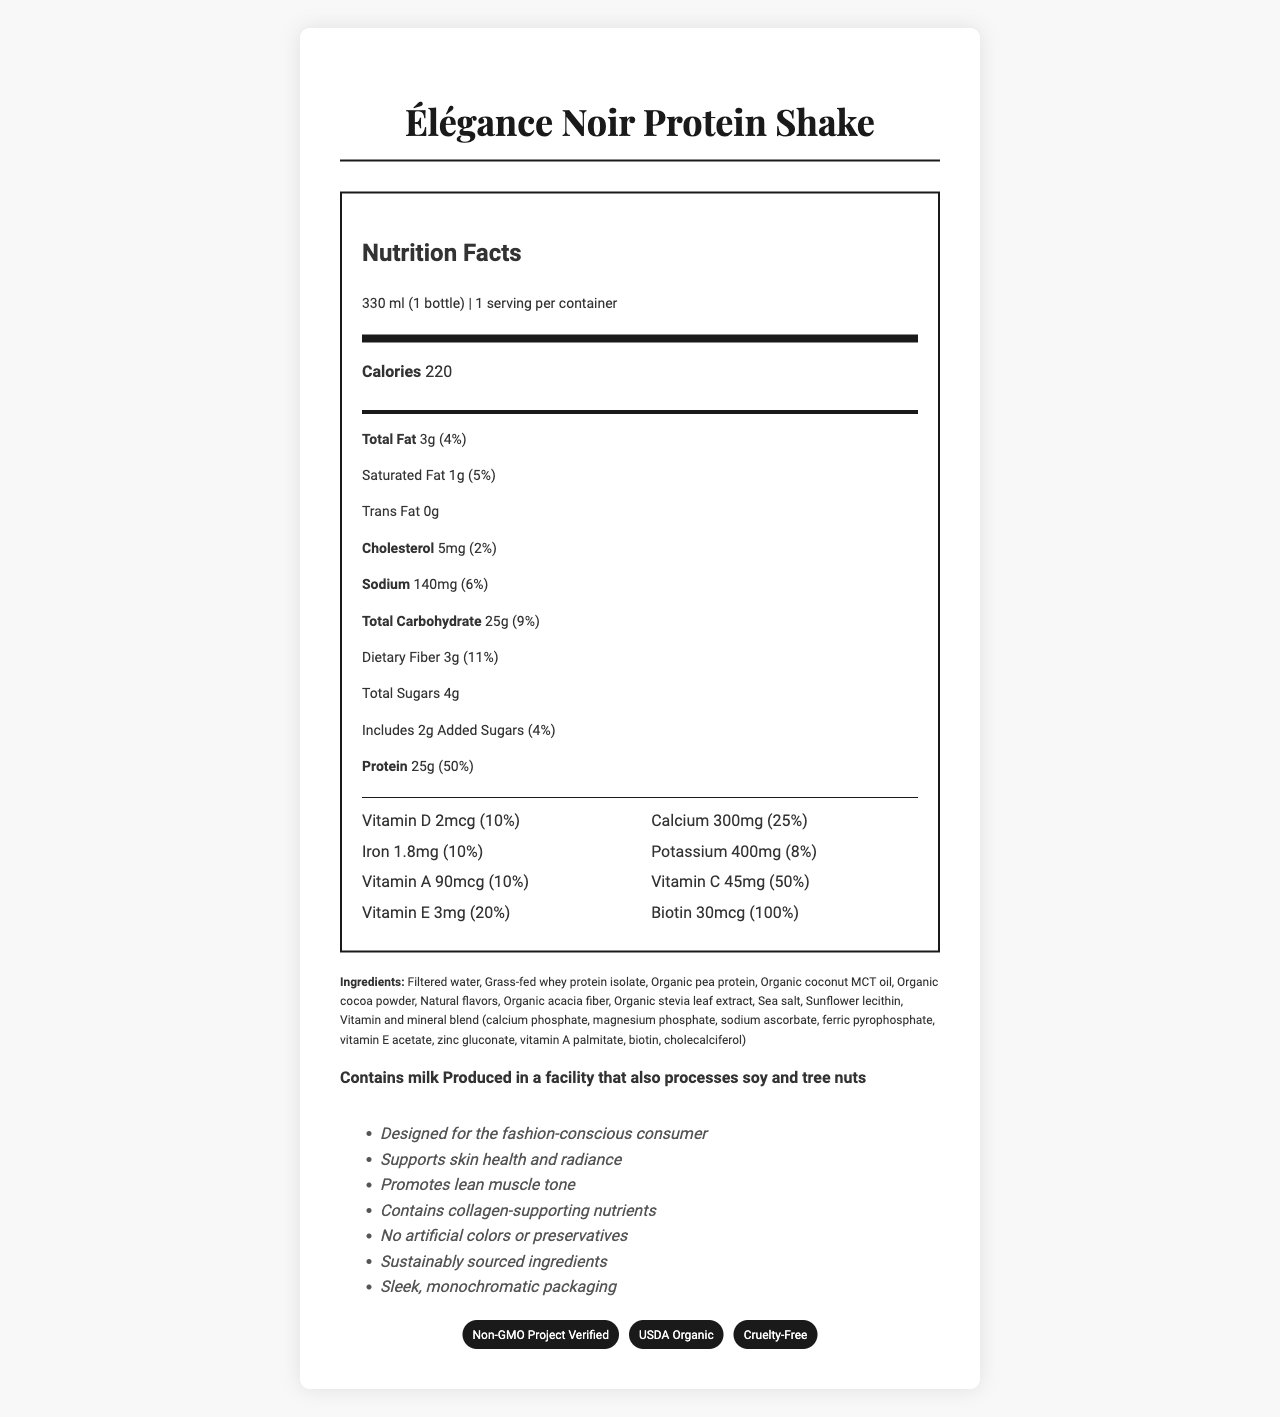what is the product name? The document clearly states the product name at the top, and in the title.
Answer: Élégance Noir Protein Shake what is the serving size for Élégance Noir Protein Shake? The serving size is mentioned in the "serving info" section just under the nutrition facts label header.
Answer: 330 ml (1 bottle) how many calories are in one serving of Élégance Noir Protein Shake? The calories count is prominently displayed in the main nutrients section.
Answer: 220 calories how much total fat does the product contain per serving? The amount of total fat is listed in the sub-nutrients section under the Total Fat label.
Answer: 3g how much protein does the shake provide per serving? The protein content is highlighted under the Protein label in the sub-nutrients section, with a Daily Value of 50%.
Answer: 25g how much added sugars are in this protein shake? The added sugars are documented in the sub-nutrients section, labeled as "Includes 2g Added Sugars (4%)".
Answer: 2g which vitamin has the highest daily value percentage? A. Vitamin D B. Vitamin E C. Vitamin C The Vitamin C amount is 45mg, which equals 50% of the daily value.
Answer: C. Vitamin C which claim is NOT made about the Élégance Noir Protein Shake? A. Contains collagen-supporting nutrients B. Promotes brain health C. No artificial colors or preservatives D. Supports skin health and radiance This claim is not listed in the marketing claims section.
Answer: B. Promotes brain health is it suitable for someone with a milk allergy? The allergens section explicitly states "Contains milk."
Answer: No describe the main idea of this document The document focuses on presenting comprehensive details about Élégance Noir Protein Shake's nutritional values, ingredients, marketing claims, and certifications.
Answer: The document provides detailed nutritional analysis and product information for Élégance Noir Protein Shake, targeting fashion-conscious consumers. It highlights the product's chic appearance, nutritional benefits, and supplementary claims about skin health and lean muscle support. Certifications, allergen information, and storage instructions are also included. how is the packaging described? The marketing claims mention the packaging as "sleek, monochromatic."
Answer: sleek, monochromatic packaging what certifications does the product have? A. USDA Organic B. Vegan C. Non-GMO Project Verified D. Gluten-Free The certifications section lists both USDA Organic and Non-GMO Project Verified among others.
Answer: A. USDA Organic and C. Non-GMO Project Verified what are the refrigeration instructions after opening the bottle? The storage instructions towards the end of the document advise to refrigerate the product after opening.
Answer: Refrigerate after opening how long can the product be stored unopened? The shelf life information mentions it can be stored for 12 months unopened.
Answer: 12 months how much calcium does the product contain? The calcium content is found in the vitamin and minerals section, listed as "Calcium 300mg (25%)."
Answer: 300mg which ingredients are part of the vitamin and mineral blend? A. Cholecalciferol B. Zinc gluconate C. Sodium citrate D. Magnesium phosphate The ingredients list includes cholecalciferol, zinc gluconate, and magnesium phosphate in the vitamin and mineral blend; sodium citrate is not mentioned.
Answer: A. Cholecalciferol, B. Zinc gluconate, D. Magnesium phosphate can the product be determined as vegan? Although ingredients like milk-derived whey protein are present, the document does not explicitly state whether it is vegan or not.
Answer: Not enough information 